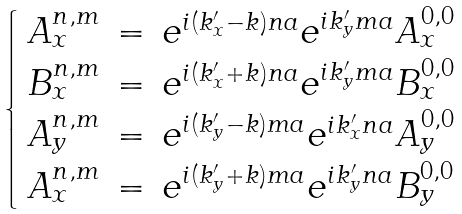Convert formula to latex. <formula><loc_0><loc_0><loc_500><loc_500>\begin{cases} \begin{array} { l c l } A _ { x } ^ { n , m } & = & e ^ { i ( k ^ { \prime } _ { x } - k ) n a } e ^ { i k ^ { \prime } _ { y } m a } A _ { x } ^ { 0 , 0 } \\ B _ { x } ^ { n , m } & = & e ^ { i ( k ^ { \prime } _ { x } + k ) n a } e ^ { i k ^ { \prime } _ { y } m a } B _ { x } ^ { 0 , 0 } \\ A _ { y } ^ { n , m } & = & e ^ { i ( k ^ { \prime } _ { y } - k ) m a } e ^ { i k ^ { \prime } _ { x } n a } A _ { y } ^ { 0 , 0 } \\ A _ { x } ^ { n , m } & = & e ^ { i ( k ^ { \prime } _ { y } + k ) m a } e ^ { i k ^ { \prime } _ { y } n a } B _ { y } ^ { 0 , 0 } \\ \end{array} \end{cases}</formula> 